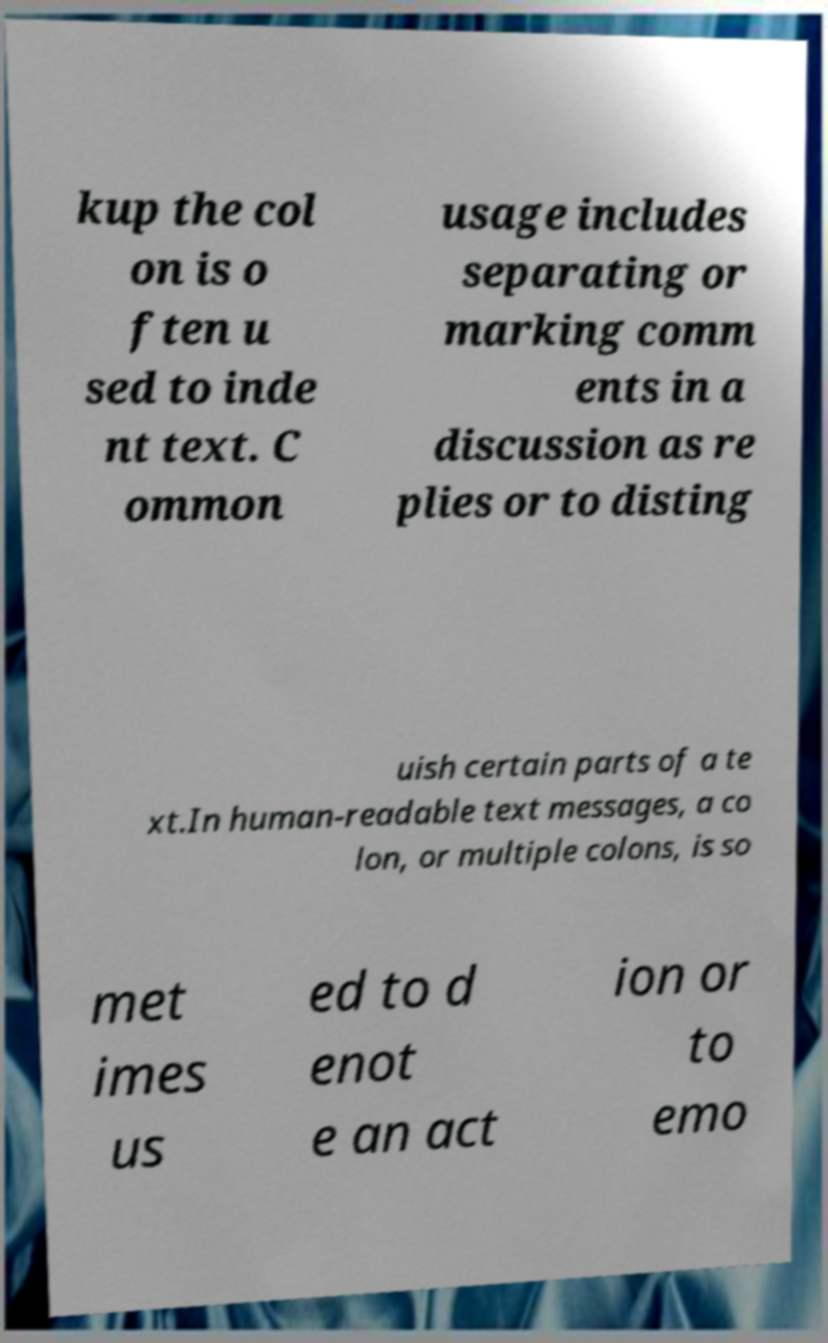Can you accurately transcribe the text from the provided image for me? kup the col on is o ften u sed to inde nt text. C ommon usage includes separating or marking comm ents in a discussion as re plies or to disting uish certain parts of a te xt.In human-readable text messages, a co lon, or multiple colons, is so met imes us ed to d enot e an act ion or to emo 